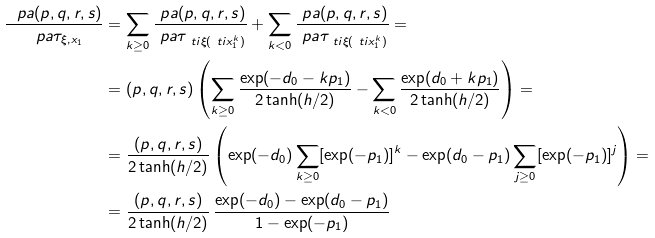Convert formula to latex. <formula><loc_0><loc_0><loc_500><loc_500>\frac { \ p a ( p , q , r , s ) } { \ p a \tau _ { \xi , x _ { 1 } } } & = \sum _ { k \geq 0 } \frac { \ p a ( p , q , r , s ) } { \ p a \tau _ { \ t i { \xi } ( \ t i { x } _ { 1 } ^ { k } ) } } + \sum _ { k < 0 } \frac { \ p a ( p , q , r , s ) } { \ p a \tau _ { \ t i { \xi } ( \ t i { x } _ { 1 } ^ { k } ) } } = \\ & = ( p , q , r , s ) \left ( \sum _ { k \geq 0 } \frac { \exp ( - d _ { 0 } - k p _ { 1 } ) } { 2 \tanh ( h / 2 ) } - \sum _ { k < 0 } \frac { \exp ( d _ { 0 } + k p _ { 1 } ) } { 2 \tanh ( h / 2 ) } \right ) = \\ & = \frac { ( p , q , r , s ) } { 2 \tanh ( h / 2 ) } \left ( \exp ( - d _ { 0 } ) \sum _ { k \geq 0 } [ \exp ( - p _ { 1 } ) ] ^ { k } - \exp ( d _ { 0 } - p _ { 1 } ) \sum _ { j \geq 0 } [ \exp ( - p _ { 1 } ) ] ^ { j } \right ) = \\ & = \frac { ( p , q , r , s ) } { 2 \tanh ( h / 2 ) } \, \frac { \exp ( - d _ { 0 } ) - \exp ( d _ { 0 } - p _ { 1 } ) } { 1 - \exp ( - p _ { 1 } ) }</formula> 